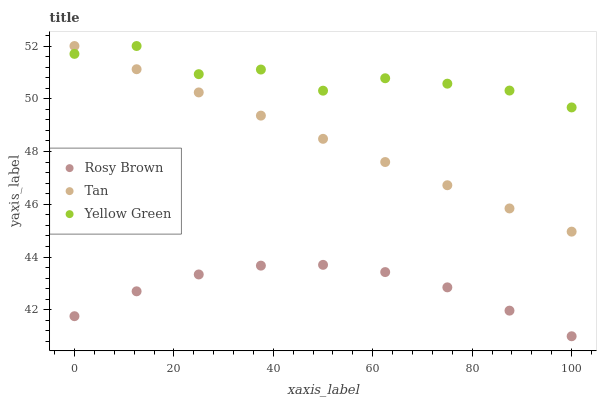Does Rosy Brown have the minimum area under the curve?
Answer yes or no. Yes. Does Yellow Green have the maximum area under the curve?
Answer yes or no. Yes. Does Yellow Green have the minimum area under the curve?
Answer yes or no. No. Does Rosy Brown have the maximum area under the curve?
Answer yes or no. No. Is Tan the smoothest?
Answer yes or no. Yes. Is Yellow Green the roughest?
Answer yes or no. Yes. Is Rosy Brown the smoothest?
Answer yes or no. No. Is Rosy Brown the roughest?
Answer yes or no. No. Does Rosy Brown have the lowest value?
Answer yes or no. Yes. Does Yellow Green have the lowest value?
Answer yes or no. No. Does Yellow Green have the highest value?
Answer yes or no. Yes. Does Rosy Brown have the highest value?
Answer yes or no. No. Is Rosy Brown less than Tan?
Answer yes or no. Yes. Is Yellow Green greater than Rosy Brown?
Answer yes or no. Yes. Does Yellow Green intersect Tan?
Answer yes or no. Yes. Is Yellow Green less than Tan?
Answer yes or no. No. Is Yellow Green greater than Tan?
Answer yes or no. No. Does Rosy Brown intersect Tan?
Answer yes or no. No. 